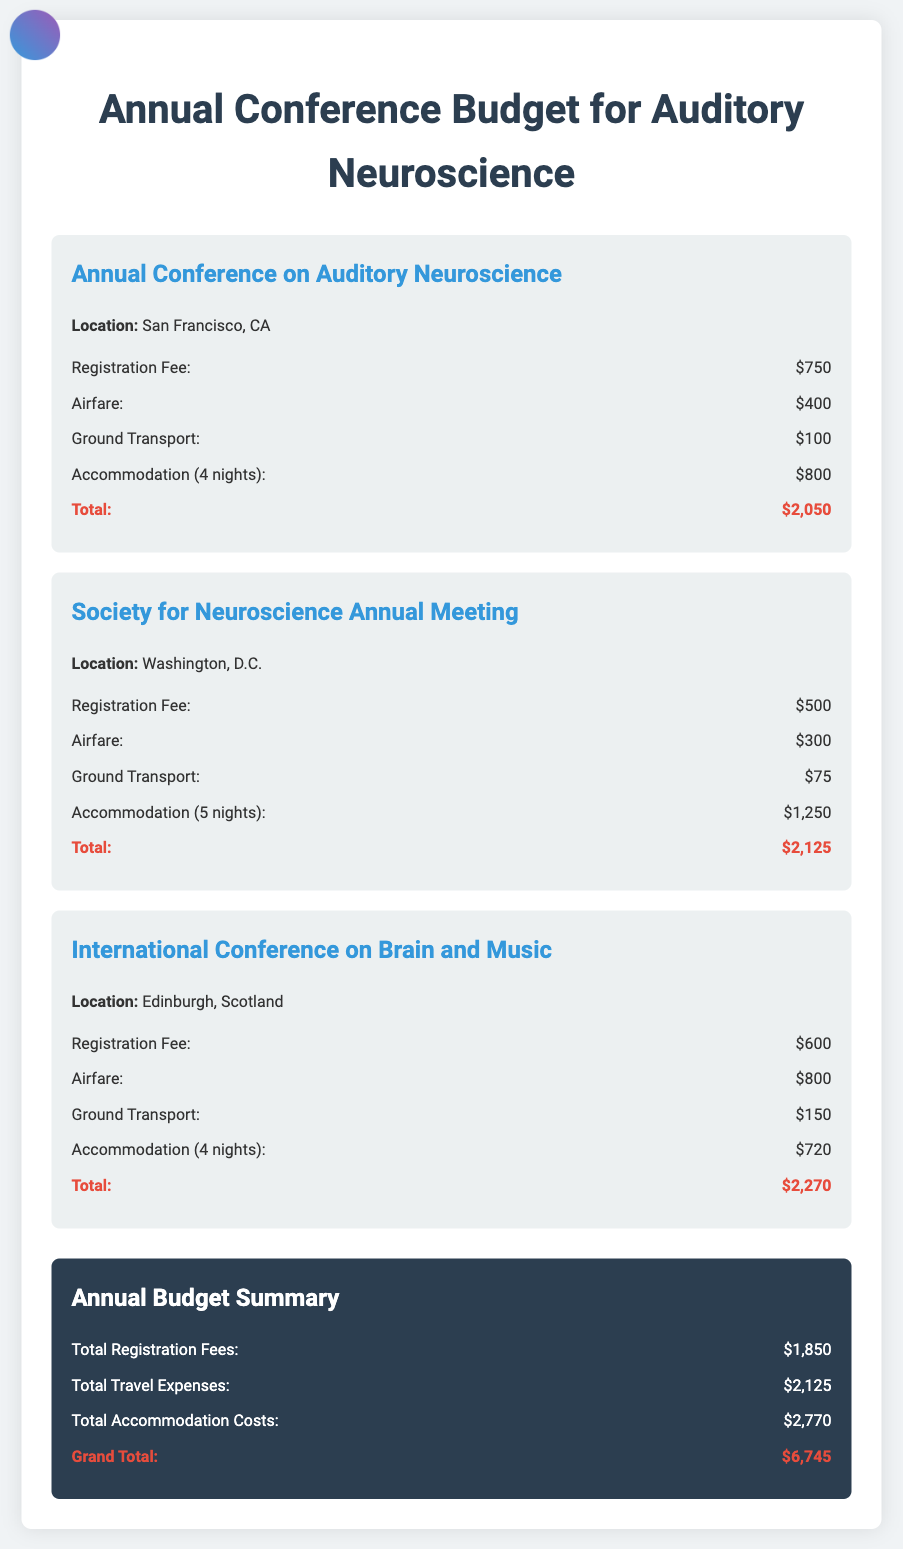what is the registration fee for the Annual Conference on Auditory Neuroscience? The registration fee listed in the document for this conference is given as $750.
Answer: $750 how much is the airfare for the International Conference on Brain and Music? The document specifies the airfare for this conference as $800.
Answer: $800 what is the total accommodation cost for the Society for Neuroscience Annual Meeting? The accommodation cost for this meeting, as stated in the document, is $1,250 for 5 nights.
Answer: $1,250 what is the grand total of the annual budget? The grand total is calculated by summing all the specified expenses, which comes to $6,745.
Answer: $6,745 which conference has the highest total expenses? By comparing total expenses for each conference in the document, the International Conference on Brain and Music has the highest total expenses of $2,270.
Answer: $2,270 what is the total cost for ground transport for all conferences? The total cost is the sum of ground transport for each conference, calculated as $100 + $75 + $150 = $325.
Answer: $325 how many nights of accommodation are provided for the Annual Conference on Auditory Neuroscience? The document states that there are 4 nights of accommodation for this conference.
Answer: 4 nights what is the total amount spent on registration fees for all conferences? The total registration fees calculated from the document are $750 + $500 + $600 = $1,850.
Answer: $1,850 which location is the Society for Neuroscience Annual Meeting held in? The document indicates that this meeting is held in Washington, D.C.
Answer: Washington, D.C 